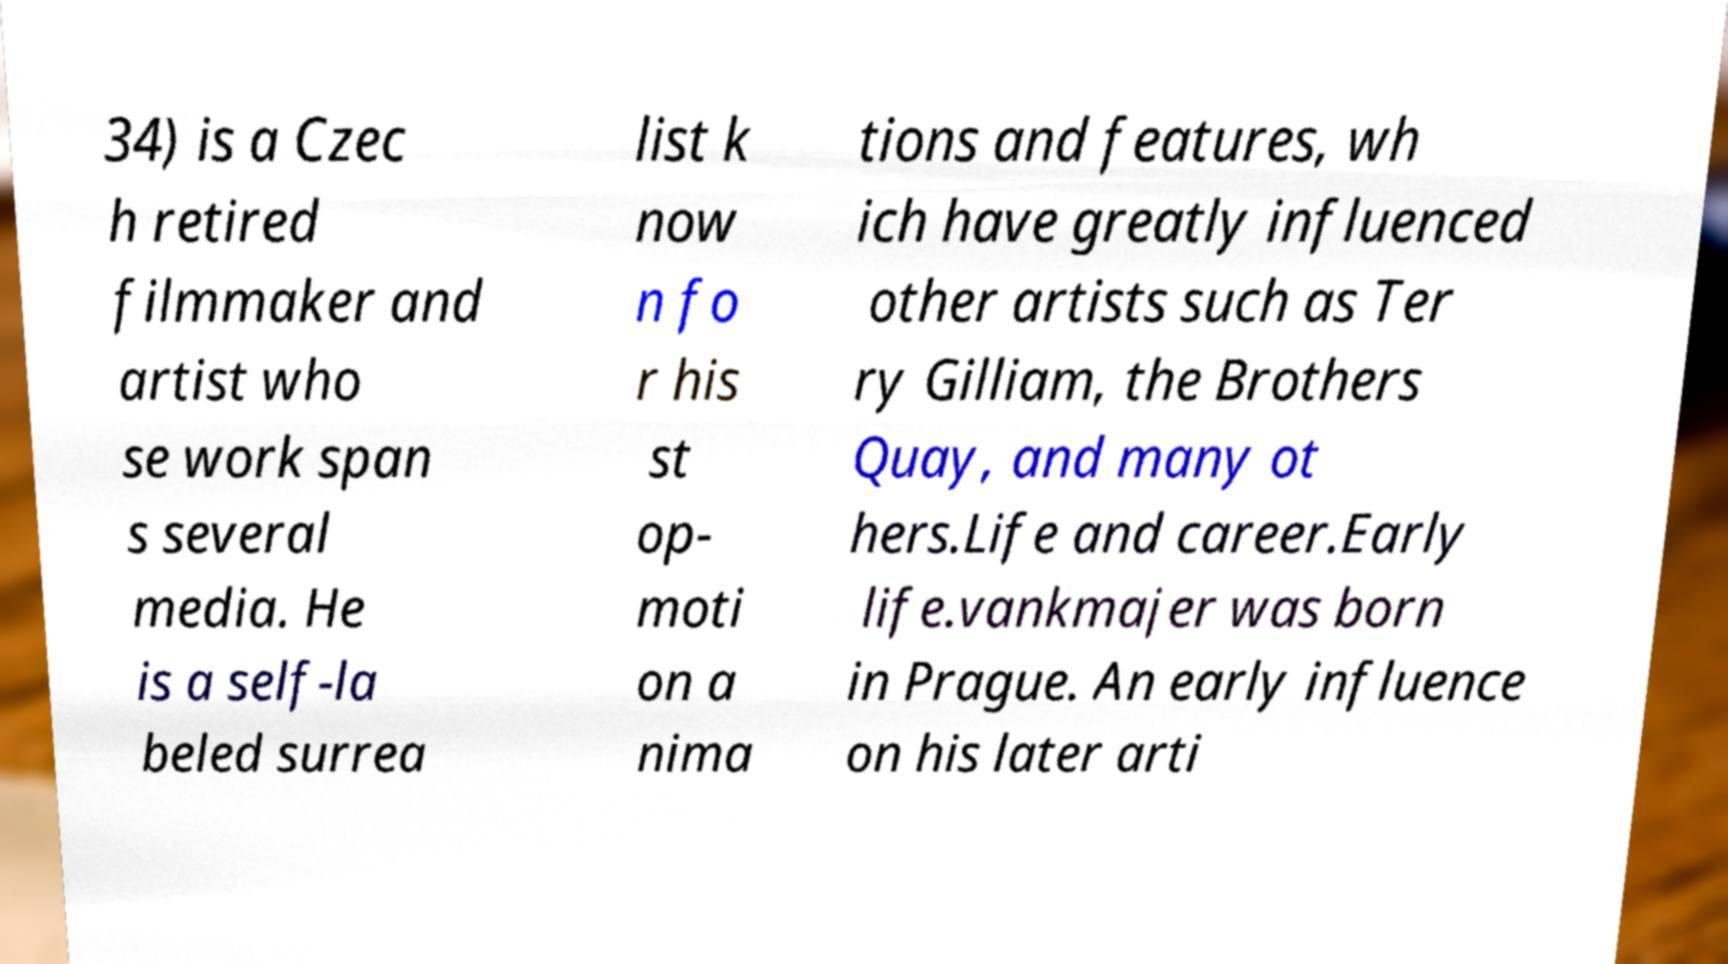Can you read and provide the text displayed in the image?This photo seems to have some interesting text. Can you extract and type it out for me? 34) is a Czec h retired filmmaker and artist who se work span s several media. He is a self-la beled surrea list k now n fo r his st op- moti on a nima tions and features, wh ich have greatly influenced other artists such as Ter ry Gilliam, the Brothers Quay, and many ot hers.Life and career.Early life.vankmajer was born in Prague. An early influence on his later arti 